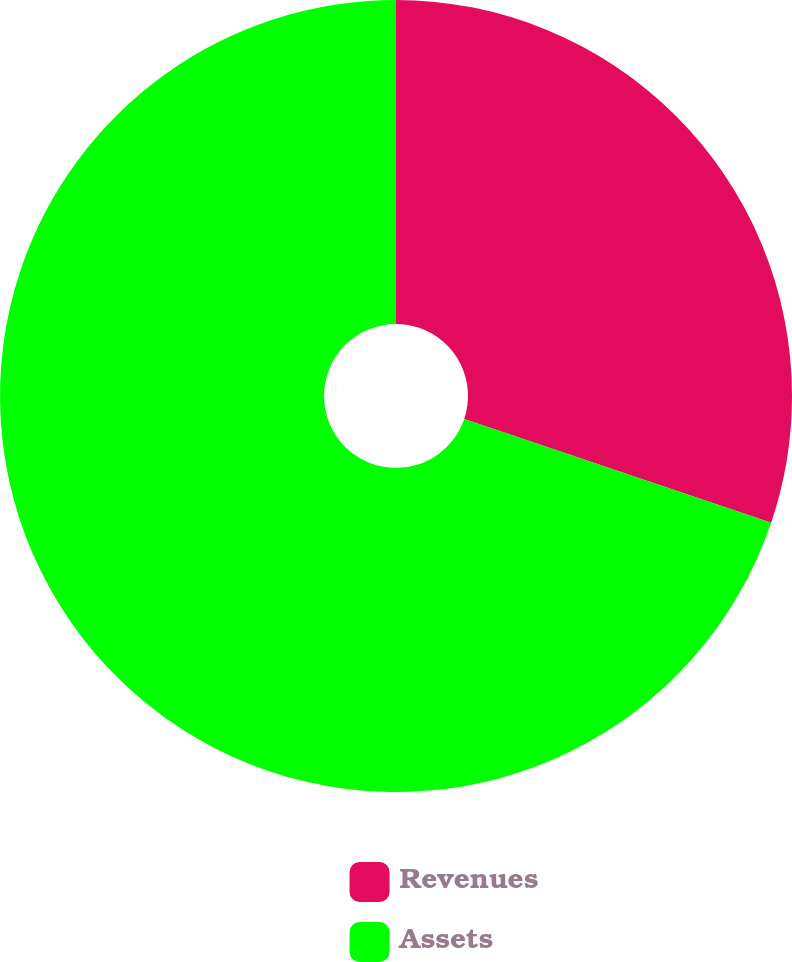Convert chart to OTSL. <chart><loc_0><loc_0><loc_500><loc_500><pie_chart><fcel>Revenues<fcel>Assets<nl><fcel>30.19%<fcel>69.81%<nl></chart> 